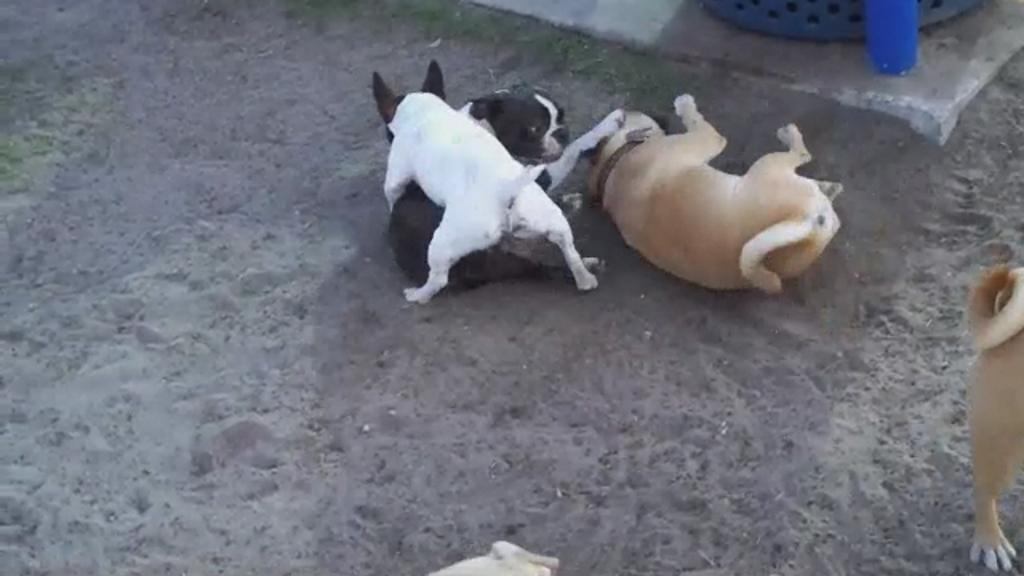What types of animals are present in the image? There are different colored dogs in the image. How many brown dogs are in the image? Two dogs are brown in color. What color is the third dog in the image? One dog is white in color. What color is the fourth dog in the image? One dog is black in color. Can you see a veil on any of the dogs in the image? No, there is no veil present on any of the dogs in the image. 